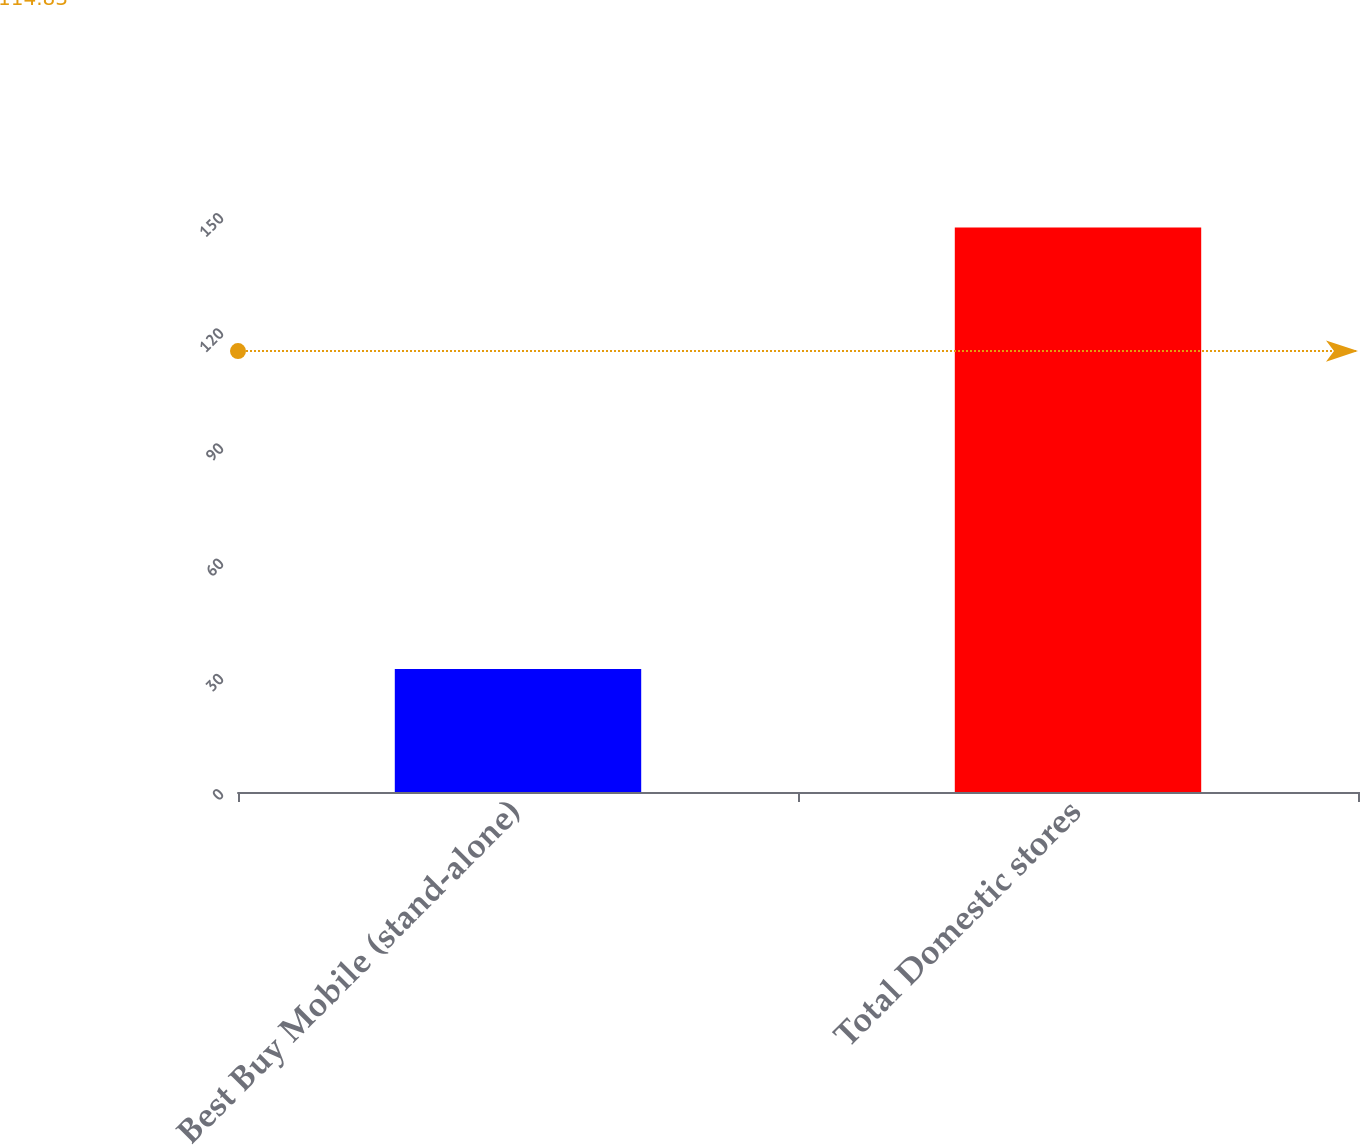Convert chart to OTSL. <chart><loc_0><loc_0><loc_500><loc_500><bar_chart><fcel>Best Buy Mobile (stand-alone)<fcel>Total Domestic stores<nl><fcel>32<fcel>147<nl></chart> 